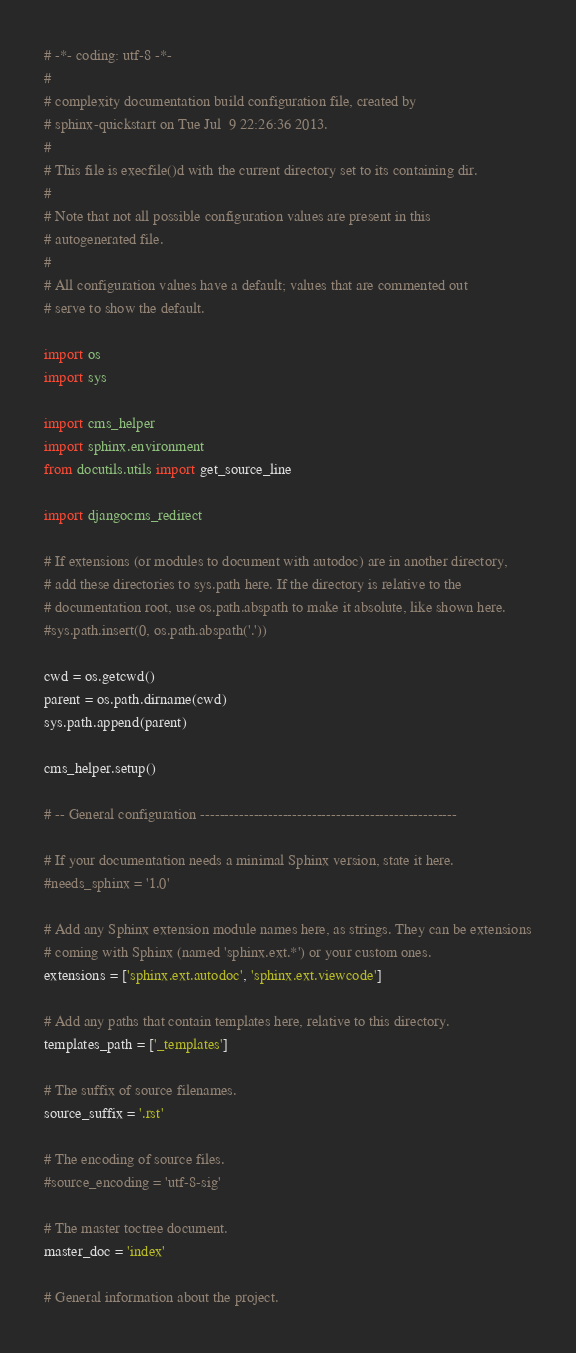Convert code to text. <code><loc_0><loc_0><loc_500><loc_500><_Python_># -*- coding: utf-8 -*-
#
# complexity documentation build configuration file, created by
# sphinx-quickstart on Tue Jul  9 22:26:36 2013.
#
# This file is execfile()d with the current directory set to its containing dir.
#
# Note that not all possible configuration values are present in this
# autogenerated file.
#
# All configuration values have a default; values that are commented out
# serve to show the default.

import os
import sys

import cms_helper
import sphinx.environment
from docutils.utils import get_source_line

import djangocms_redirect

# If extensions (or modules to document with autodoc) are in another directory,
# add these directories to sys.path here. If the directory is relative to the
# documentation root, use os.path.abspath to make it absolute, like shown here.
#sys.path.insert(0, os.path.abspath('.'))

cwd = os.getcwd()
parent = os.path.dirname(cwd)
sys.path.append(parent)

cms_helper.setup()

# -- General configuration -----------------------------------------------------

# If your documentation needs a minimal Sphinx version, state it here.
#needs_sphinx = '1.0'

# Add any Sphinx extension module names here, as strings. They can be extensions
# coming with Sphinx (named 'sphinx.ext.*') or your custom ones.
extensions = ['sphinx.ext.autodoc', 'sphinx.ext.viewcode']

# Add any paths that contain templates here, relative to this directory.
templates_path = ['_templates']

# The suffix of source filenames.
source_suffix = '.rst'

# The encoding of source files.
#source_encoding = 'utf-8-sig'

# The master toctree document.
master_doc = 'index'

# General information about the project.</code> 